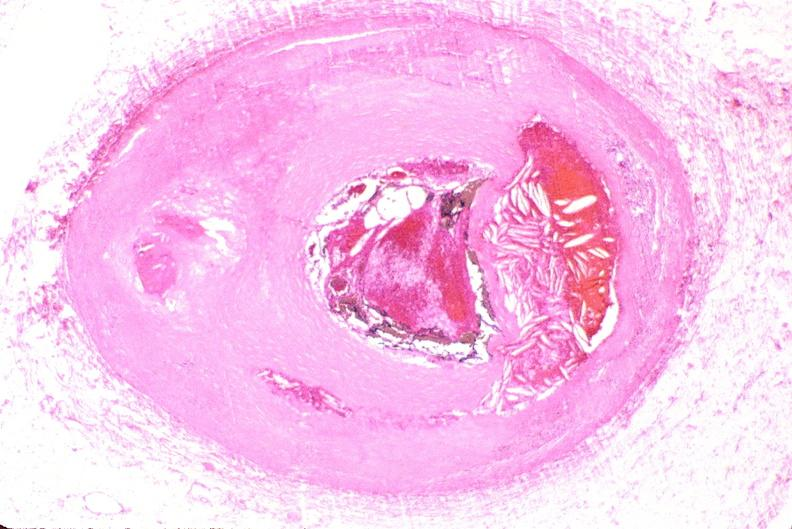where is this from?
Answer the question using a single word or phrase. Vasculature 